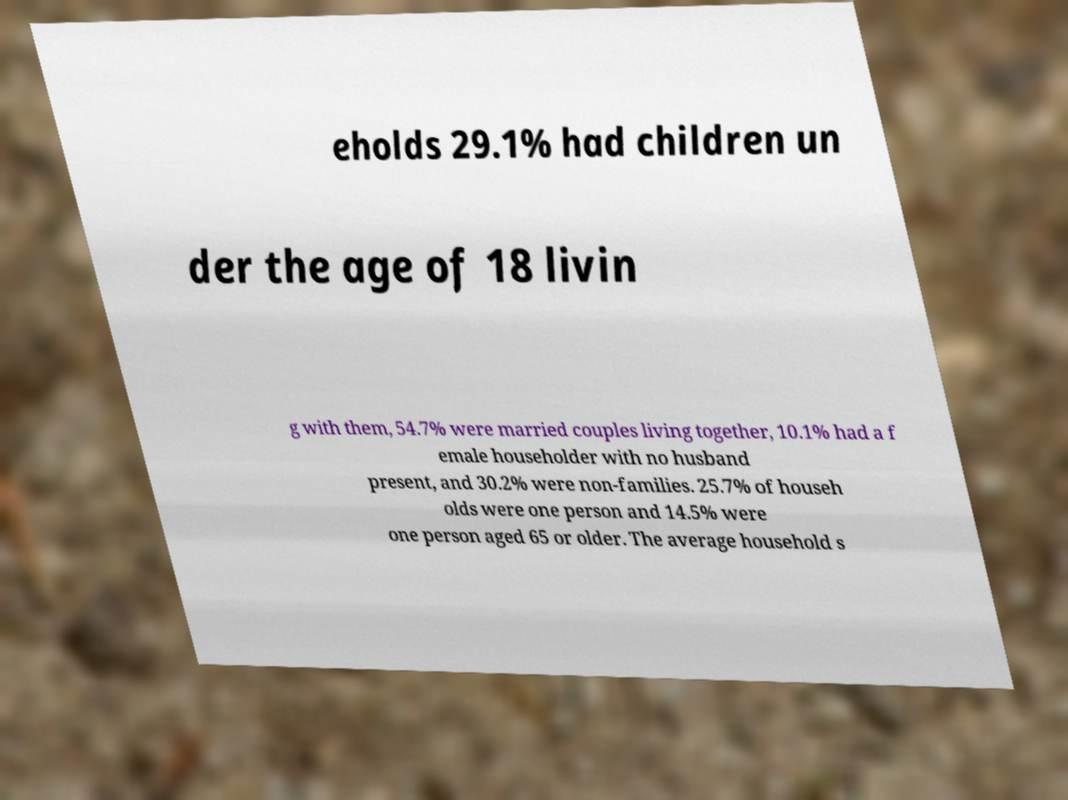Can you accurately transcribe the text from the provided image for me? eholds 29.1% had children un der the age of 18 livin g with them, 54.7% were married couples living together, 10.1% had a f emale householder with no husband present, and 30.2% were non-families. 25.7% of househ olds were one person and 14.5% were one person aged 65 or older. The average household s 